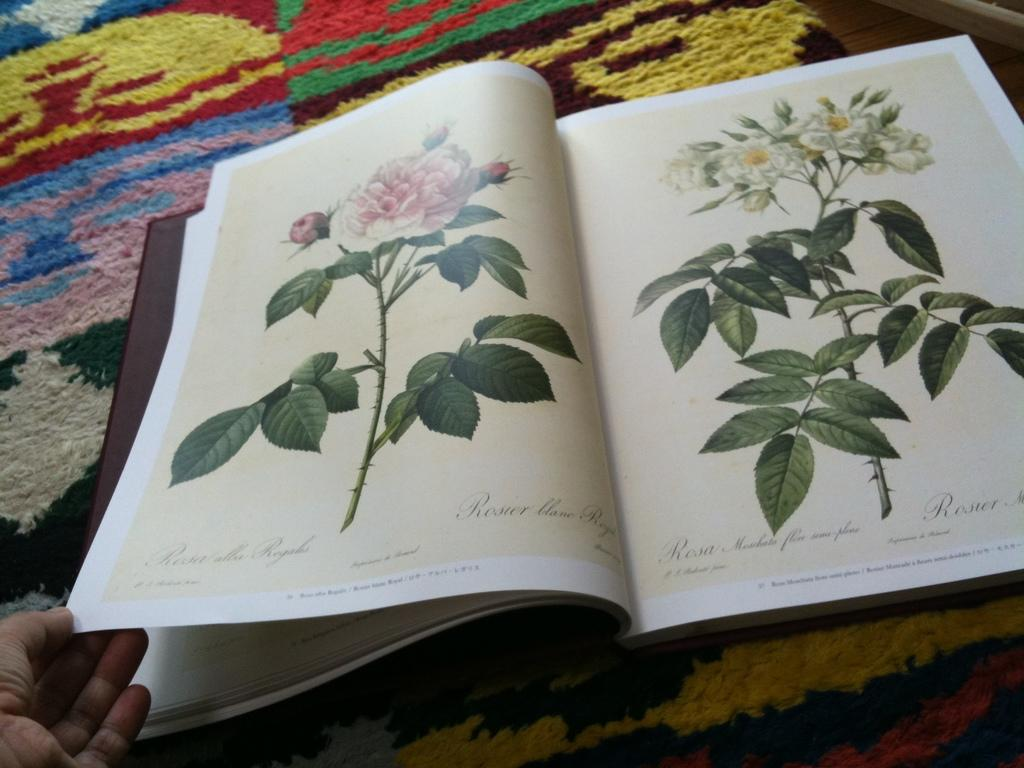<image>
Give a short and clear explanation of the subsequent image. Open book with flower pictures from Rosa Marshato. 